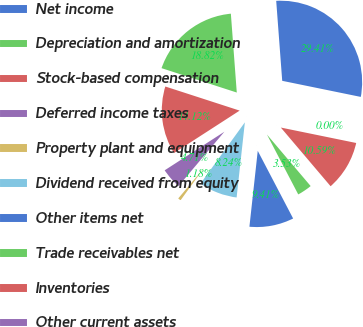Convert chart to OTSL. <chart><loc_0><loc_0><loc_500><loc_500><pie_chart><fcel>Net income<fcel>Depreciation and amortization<fcel>Stock-based compensation<fcel>Deferred income taxes<fcel>Property plant and equipment<fcel>Dividend received from equity<fcel>Other items net<fcel>Trade receivables net<fcel>Inventories<fcel>Other current assets<nl><fcel>29.41%<fcel>18.82%<fcel>14.12%<fcel>4.71%<fcel>1.18%<fcel>8.24%<fcel>9.41%<fcel>3.53%<fcel>10.59%<fcel>0.0%<nl></chart> 